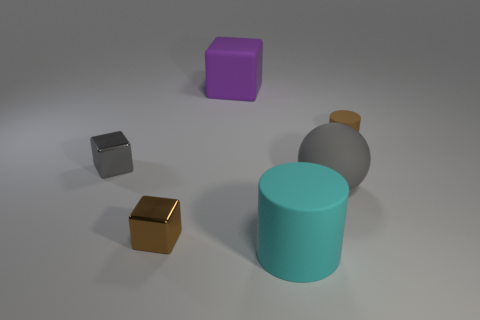How many objects are there, and can you describe their shapes? There are five objects in the image. Starting from the left, there is a small dark grey cube, followed by a tiny brown cube, a large cyan cylinder, a larger grey cube, and lastly, a small purple cube. 